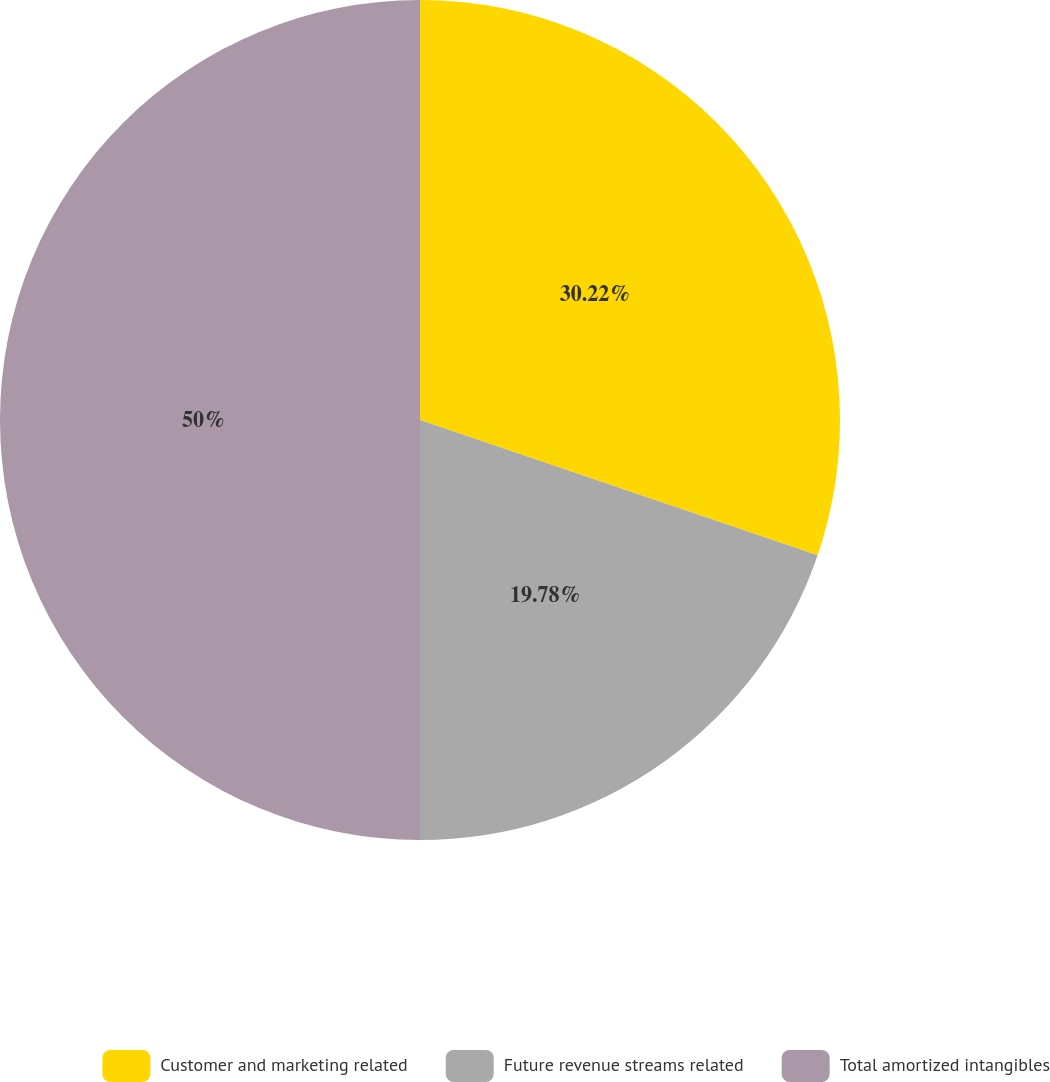Convert chart. <chart><loc_0><loc_0><loc_500><loc_500><pie_chart><fcel>Customer and marketing related<fcel>Future revenue streams related<fcel>Total amortized intangibles<nl><fcel>30.22%<fcel>19.78%<fcel>50.0%<nl></chart> 